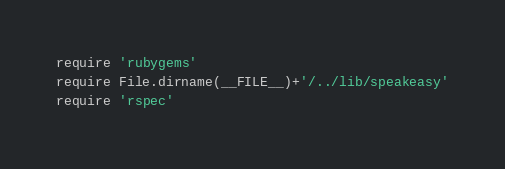Convert code to text. <code><loc_0><loc_0><loc_500><loc_500><_Ruby_>require 'rubygems'
require File.dirname(__FILE__)+'/../lib/speakeasy'
require 'rspec'
</code> 